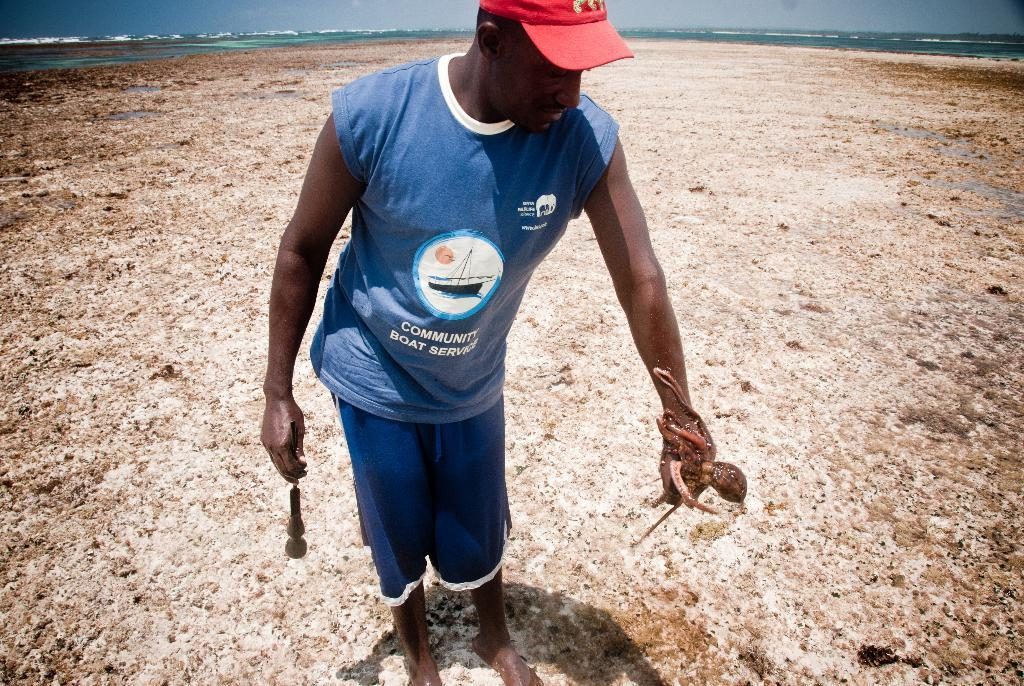What is the person in the image doing? The person is standing in the image and holding an object and an octopus. Can you describe the background of the image? There is water and the sky visible in the background of the image. What type of scent can be detected from the octopus in the image? There is no indication of a scent in the image, as it is a visual representation. 